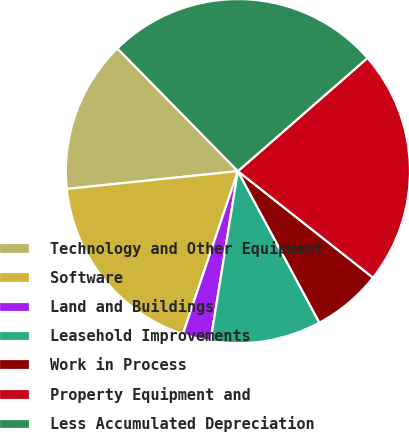<chart> <loc_0><loc_0><loc_500><loc_500><pie_chart><fcel>Technology and Other Equipment<fcel>Software<fcel>Land and Buildings<fcel>Leasehold Improvements<fcel>Work in Process<fcel>Property Equipment and<fcel>Less Accumulated Depreciation<nl><fcel>14.29%<fcel>18.17%<fcel>2.64%<fcel>10.4%<fcel>6.52%<fcel>22.05%<fcel>25.93%<nl></chart> 